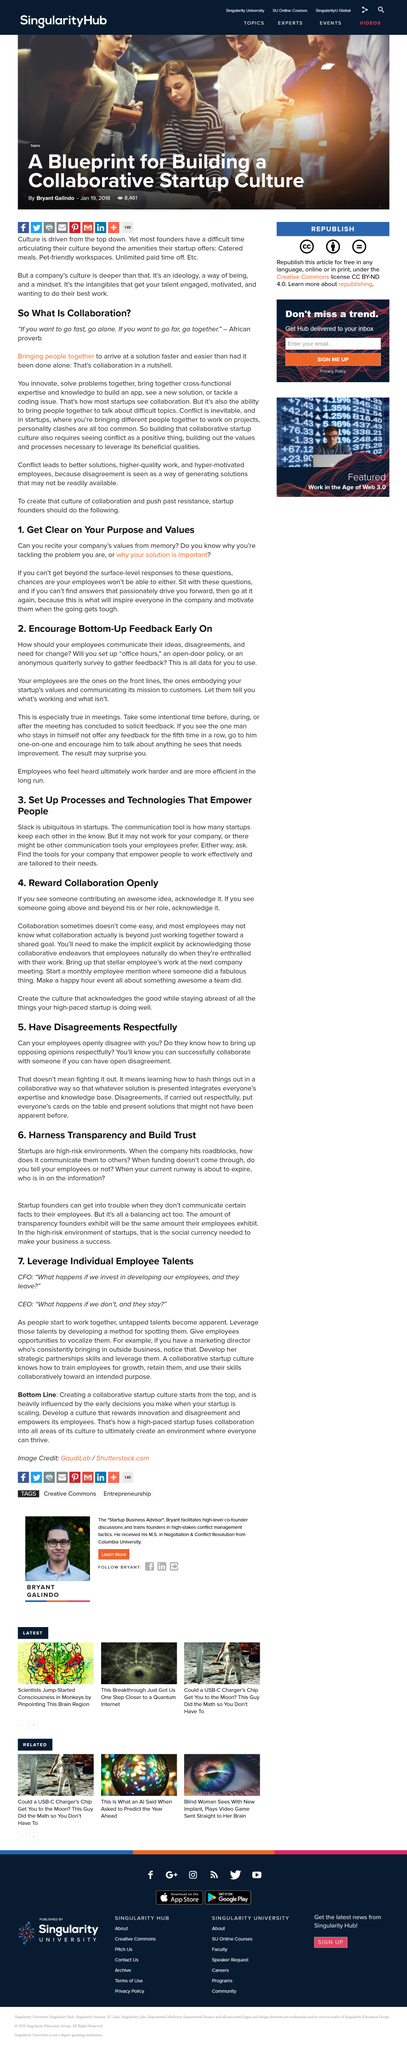Give some essential details in this illustration. The decision to encourage bottom-up feedback should be made at an early stage to facilitate effective communication and collaboration among team members. By clearly defining the purpose and values of our company, we can inspire and motivate our employees to achieve their full potential and contribute to our collective success. Yes, my employees are able to openly disagree with me, but this does not result in confrontational or hostile interactions. The methods of facilitating communication from employees in the office include holding office hours, implementing an open-door policy, and conducting anonymous quarterly surveys. It is important to solicit feedback during meetings as it allows for the exchange of ideas and opinions, which can lead to improved decision-making and collaboration. 